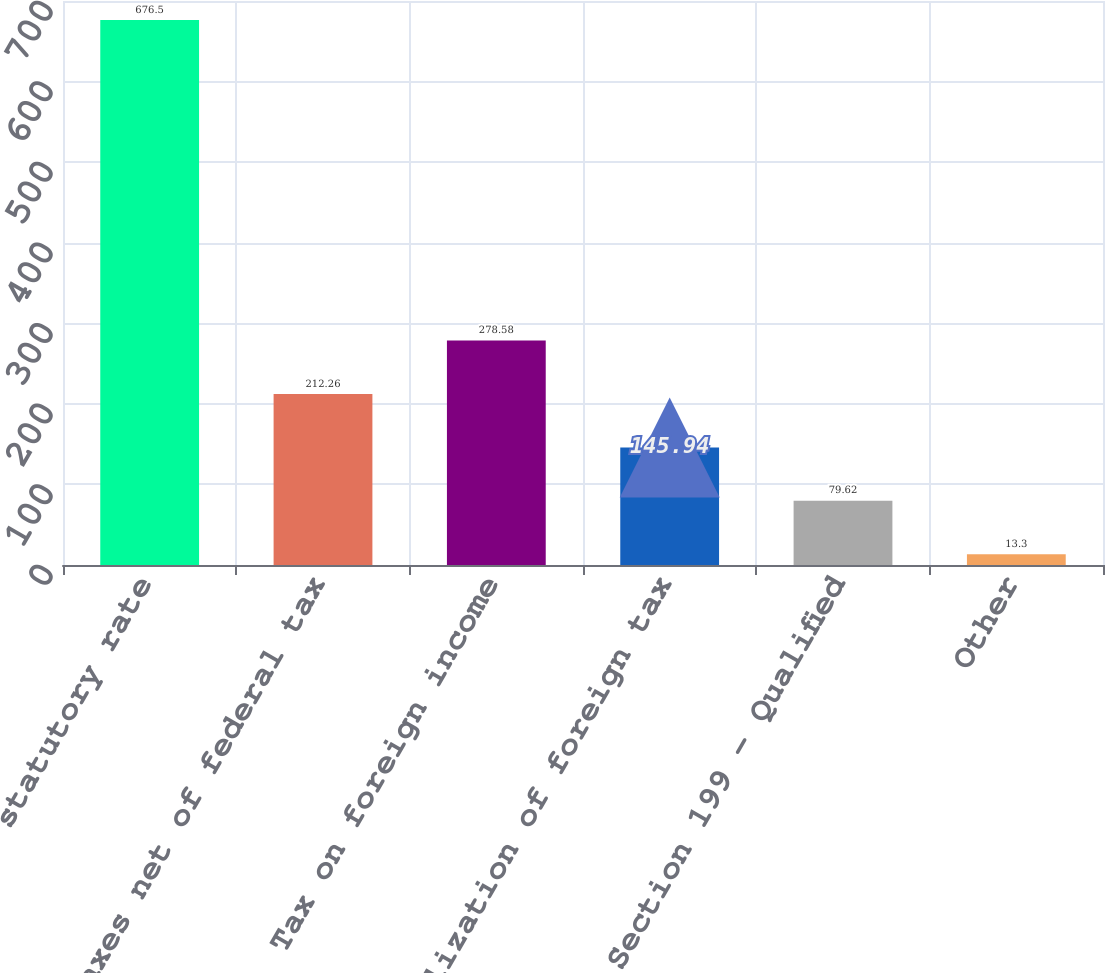Convert chart to OTSL. <chart><loc_0><loc_0><loc_500><loc_500><bar_chart><fcel>statutory rate<fcel>State taxes net of federal tax<fcel>Tax on foreign income<fcel>Utilization of foreign tax<fcel>Section 199 - Qualified<fcel>Other<nl><fcel>676.5<fcel>212.26<fcel>278.58<fcel>145.94<fcel>79.62<fcel>13.3<nl></chart> 